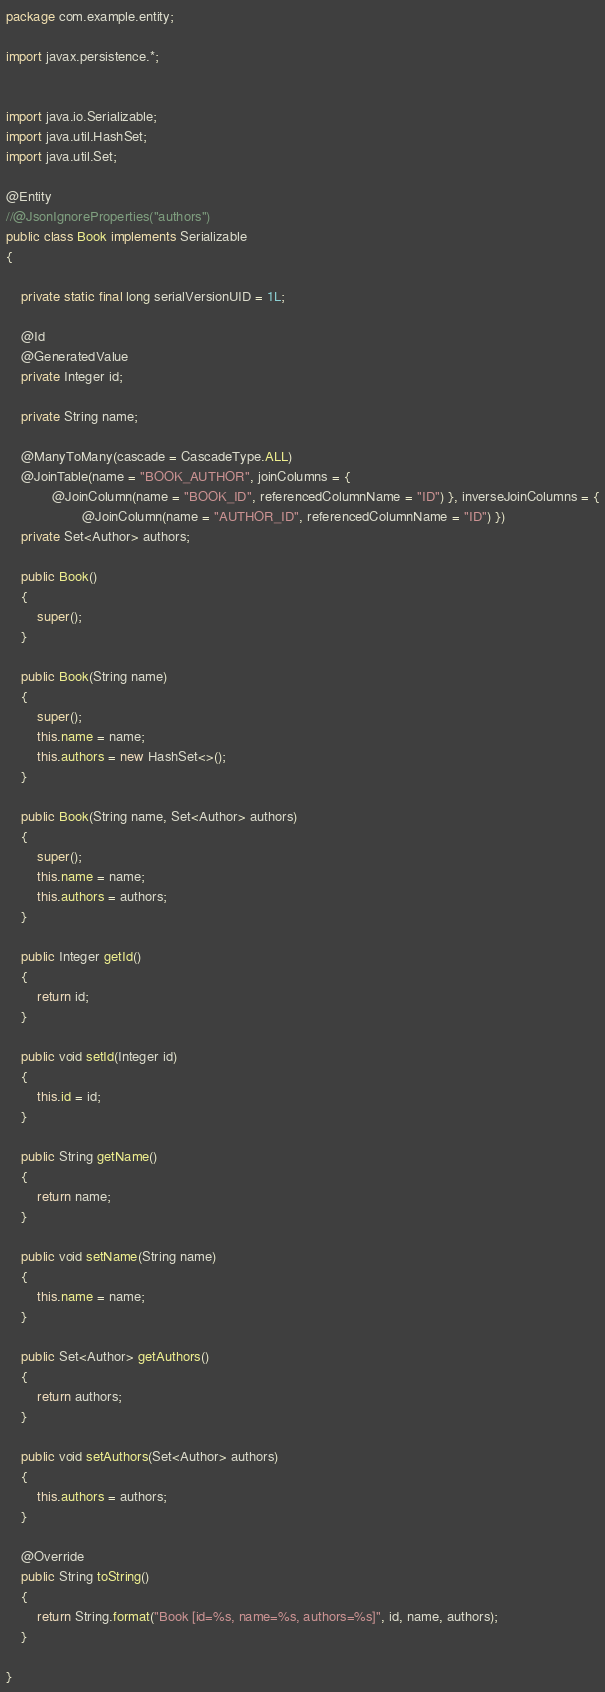<code> <loc_0><loc_0><loc_500><loc_500><_Java_>package com.example.entity;

import javax.persistence.*;


import java.io.Serializable;
import java.util.HashSet;
import java.util.Set;

@Entity
//@JsonIgnoreProperties("authors")
public class Book implements Serializable
{

    private static final long serialVersionUID = 1L;

    @Id
    @GeneratedValue
    private Integer id;

    private String name;

    @ManyToMany(cascade = CascadeType.ALL)
    @JoinTable(name = "BOOK_AUTHOR", joinColumns = {
            @JoinColumn(name = "BOOK_ID", referencedColumnName = "ID") }, inverseJoinColumns = {
                    @JoinColumn(name = "AUTHOR_ID", referencedColumnName = "ID") })
    private Set<Author> authors;

    public Book()
    {
        super();
    }

    public Book(String name)
    {
        super();
        this.name = name;
        this.authors = new HashSet<>();
    }

    public Book(String name, Set<Author> authors)
    {
        super();
        this.name = name;
        this.authors = authors;
    }

    public Integer getId()
    {
        return id;
    }

    public void setId(Integer id)
    {
        this.id = id;
    }

    public String getName()
    {
        return name;
    }

    public void setName(String name)
    {
        this.name = name;
    }

    public Set<Author> getAuthors()
    {
        return authors;
    }

    public void setAuthors(Set<Author> authors)
    {
        this.authors = authors;
    }

    @Override
    public String toString()
    {
        return String.format("Book [id=%s, name=%s, authors=%s]", id, name, authors);
    }

}
</code> 